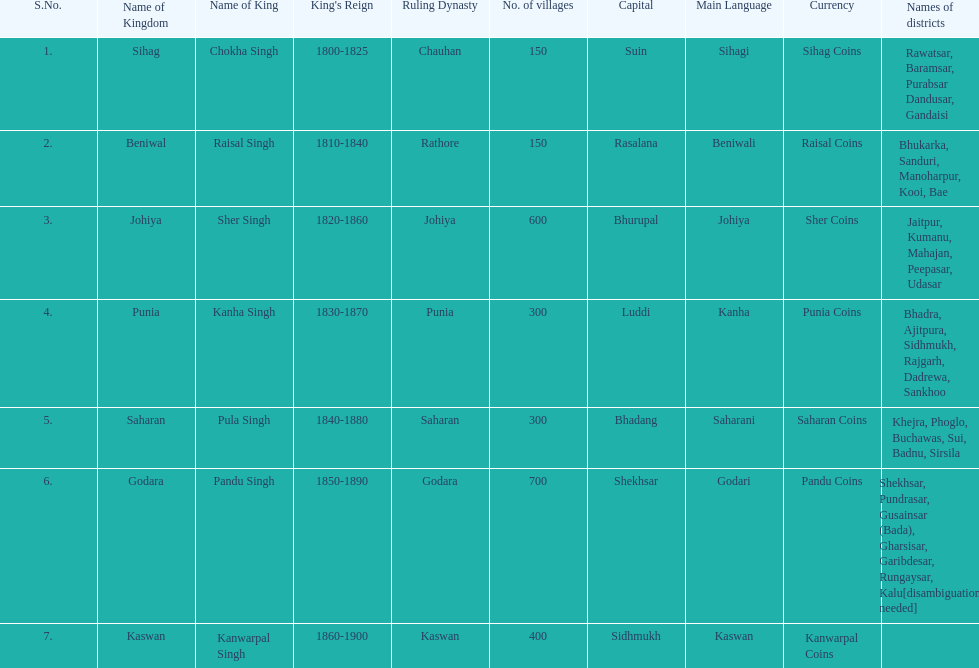He was the king of the sihag kingdom. Chokha Singh. 